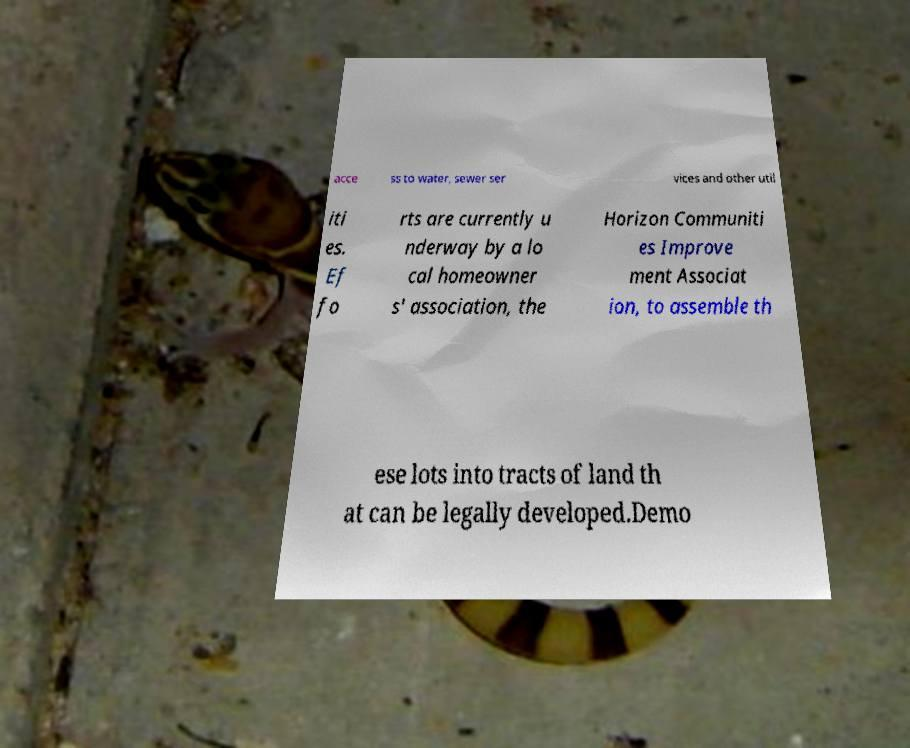For documentation purposes, I need the text within this image transcribed. Could you provide that? acce ss to water, sewer ser vices and other util iti es. Ef fo rts are currently u nderway by a lo cal homeowner s' association, the Horizon Communiti es Improve ment Associat ion, to assemble th ese lots into tracts of land th at can be legally developed.Demo 